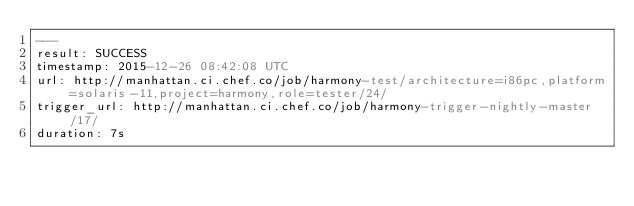<code> <loc_0><loc_0><loc_500><loc_500><_YAML_>---
result: SUCCESS
timestamp: 2015-12-26 08:42:08 UTC
url: http://manhattan.ci.chef.co/job/harmony-test/architecture=i86pc,platform=solaris-11,project=harmony,role=tester/24/
trigger_url: http://manhattan.ci.chef.co/job/harmony-trigger-nightly-master/17/
duration: 7s
</code> 